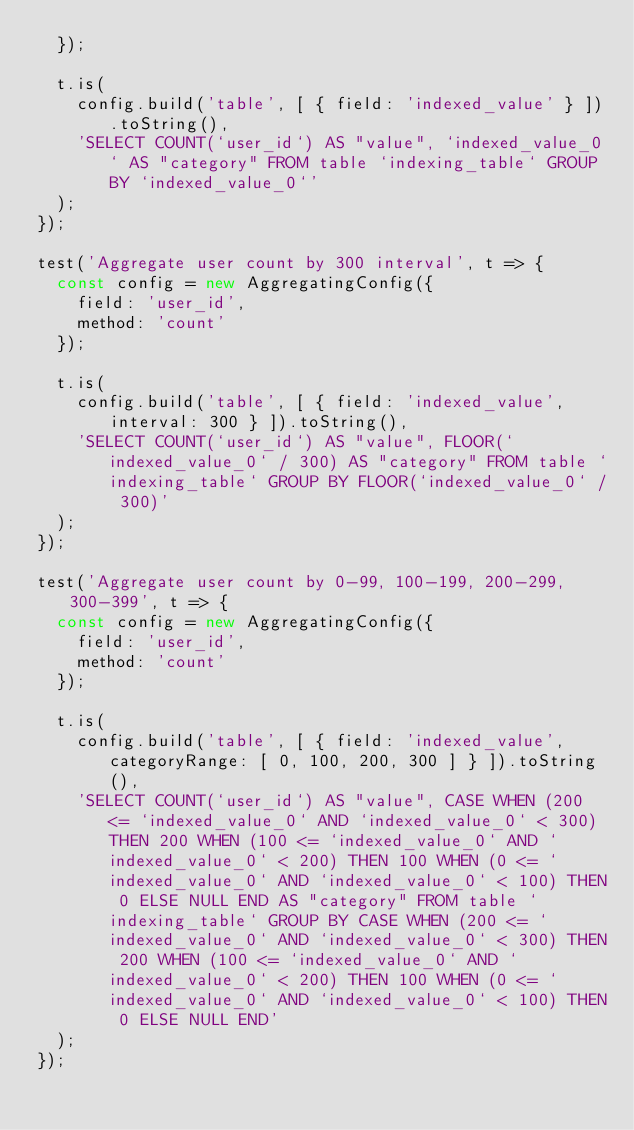Convert code to text. <code><loc_0><loc_0><loc_500><loc_500><_JavaScript_>  });

  t.is(
    config.build('table', [ { field: 'indexed_value' } ]).toString(),
    'SELECT COUNT(`user_id`) AS "value", `indexed_value_0` AS "category" FROM table `indexing_table` GROUP BY `indexed_value_0`'
  );
});

test('Aggregate user count by 300 interval', t => {
  const config = new AggregatingConfig({
    field: 'user_id',
    method: 'count'
  });

  t.is(
    config.build('table', [ { field: 'indexed_value', interval: 300 } ]).toString(),
    'SELECT COUNT(`user_id`) AS "value", FLOOR(`indexed_value_0` / 300) AS "category" FROM table `indexing_table` GROUP BY FLOOR(`indexed_value_0` / 300)'
  );
});

test('Aggregate user count by 0-99, 100-199, 200-299, 300-399', t => {
  const config = new AggregatingConfig({
    field: 'user_id',
    method: 'count'
  });

  t.is(
    config.build('table', [ { field: 'indexed_value', categoryRange: [ 0, 100, 200, 300 ] } ]).toString(),
    'SELECT COUNT(`user_id`) AS "value", CASE WHEN (200 <= `indexed_value_0` AND `indexed_value_0` < 300) THEN 200 WHEN (100 <= `indexed_value_0` AND `indexed_value_0` < 200) THEN 100 WHEN (0 <= `indexed_value_0` AND `indexed_value_0` < 100) THEN 0 ELSE NULL END AS "category" FROM table `indexing_table` GROUP BY CASE WHEN (200 <= `indexed_value_0` AND `indexed_value_0` < 300) THEN 200 WHEN (100 <= `indexed_value_0` AND `indexed_value_0` < 200) THEN 100 WHEN (0 <= `indexed_value_0` AND `indexed_value_0` < 100) THEN 0 ELSE NULL END'
  );
});
</code> 